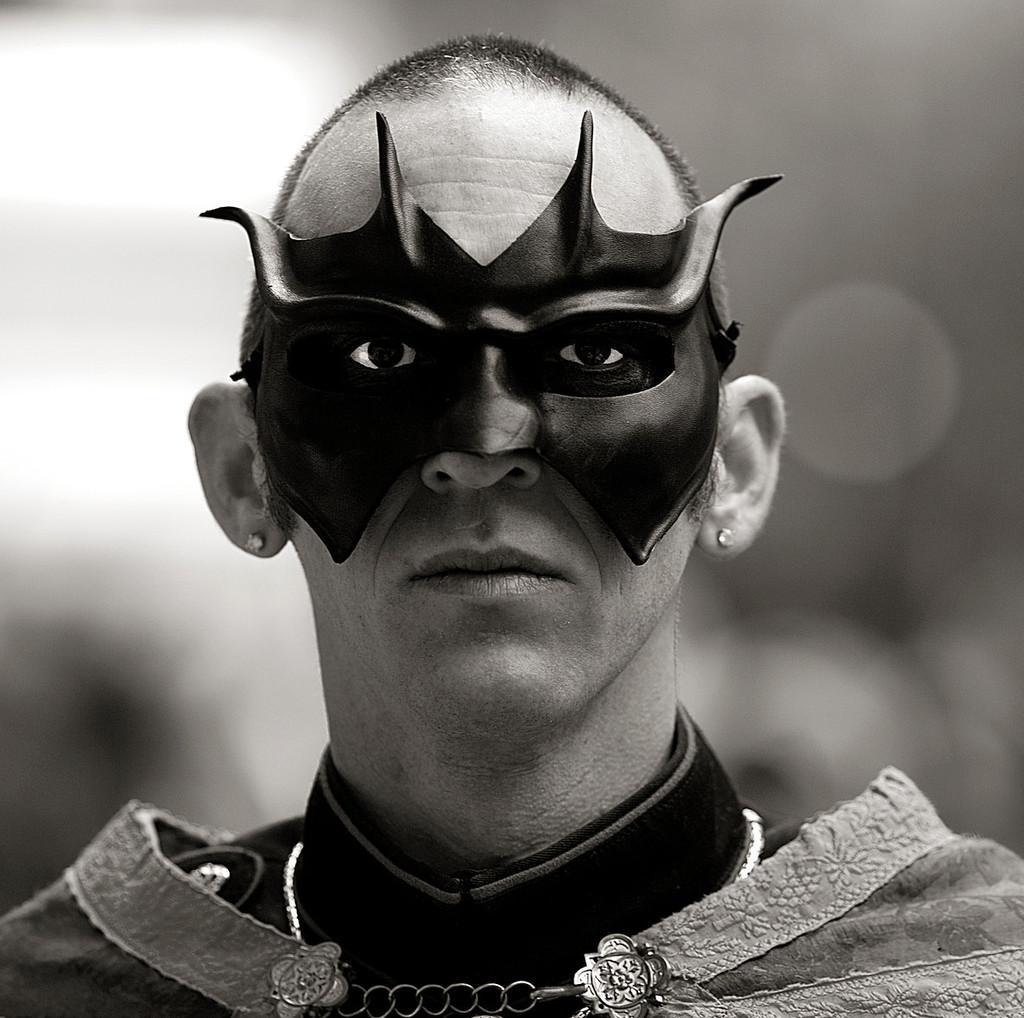Can you describe this image briefly? This is a black and white picture. Here we can see a person and he wore a mask. There is a blur background. 